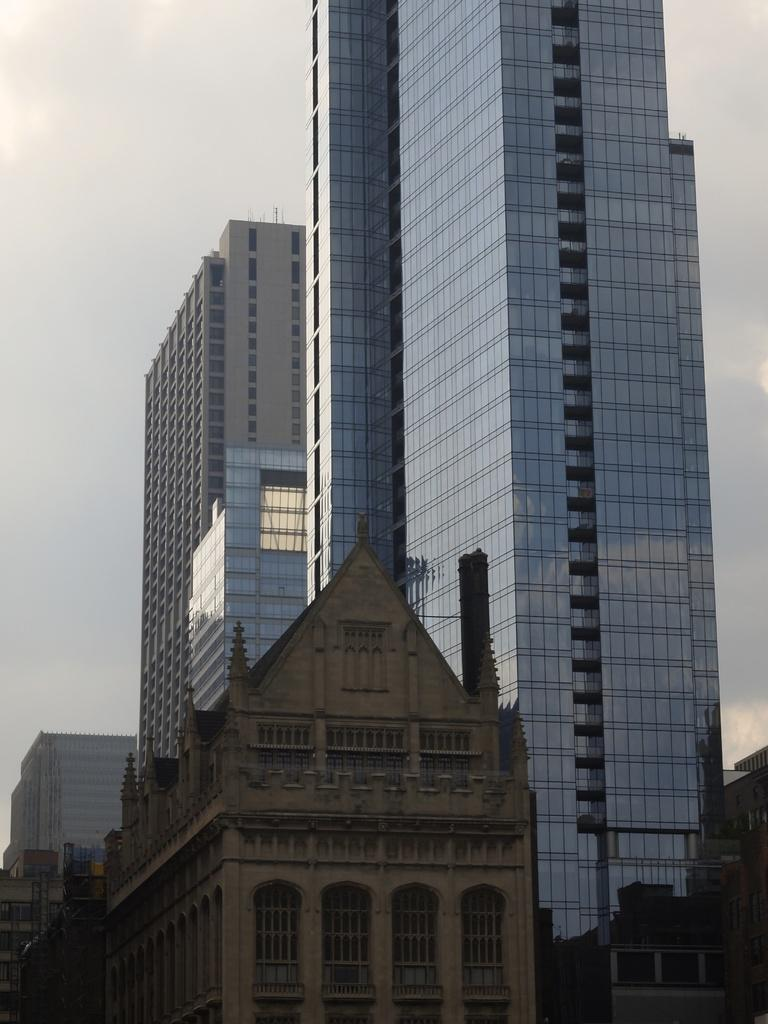What type of structures can be seen in the image? There are buildings in the image. What date is marked on the calendar in the image? There is no calendar present in the image. What type of weapon is visible in the image? There is no weapon, such as a cannon, present in the image. 